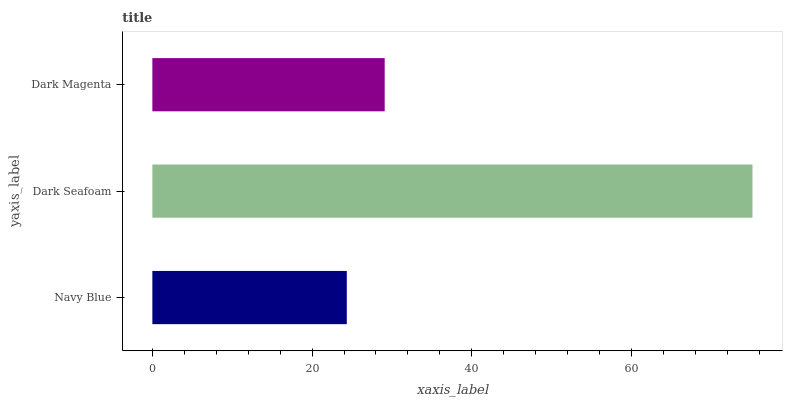Is Navy Blue the minimum?
Answer yes or no. Yes. Is Dark Seafoam the maximum?
Answer yes or no. Yes. Is Dark Magenta the minimum?
Answer yes or no. No. Is Dark Magenta the maximum?
Answer yes or no. No. Is Dark Seafoam greater than Dark Magenta?
Answer yes or no. Yes. Is Dark Magenta less than Dark Seafoam?
Answer yes or no. Yes. Is Dark Magenta greater than Dark Seafoam?
Answer yes or no. No. Is Dark Seafoam less than Dark Magenta?
Answer yes or no. No. Is Dark Magenta the high median?
Answer yes or no. Yes. Is Dark Magenta the low median?
Answer yes or no. Yes. Is Navy Blue the high median?
Answer yes or no. No. Is Dark Seafoam the low median?
Answer yes or no. No. 